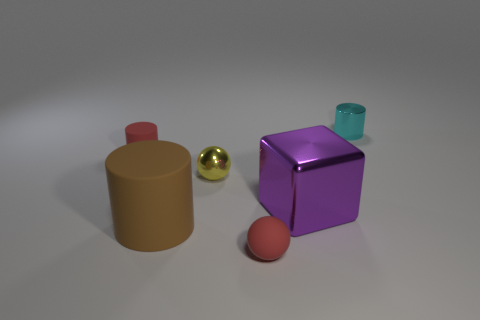Are there any rubber cylinders that are in front of the red thing that is behind the tiny thing that is in front of the big purple shiny object? Yes, there is a rubber cylinder in front of the red sphere that is behind the small golden sphere, which in turn is situated in front of the large purple, shiny cube. 